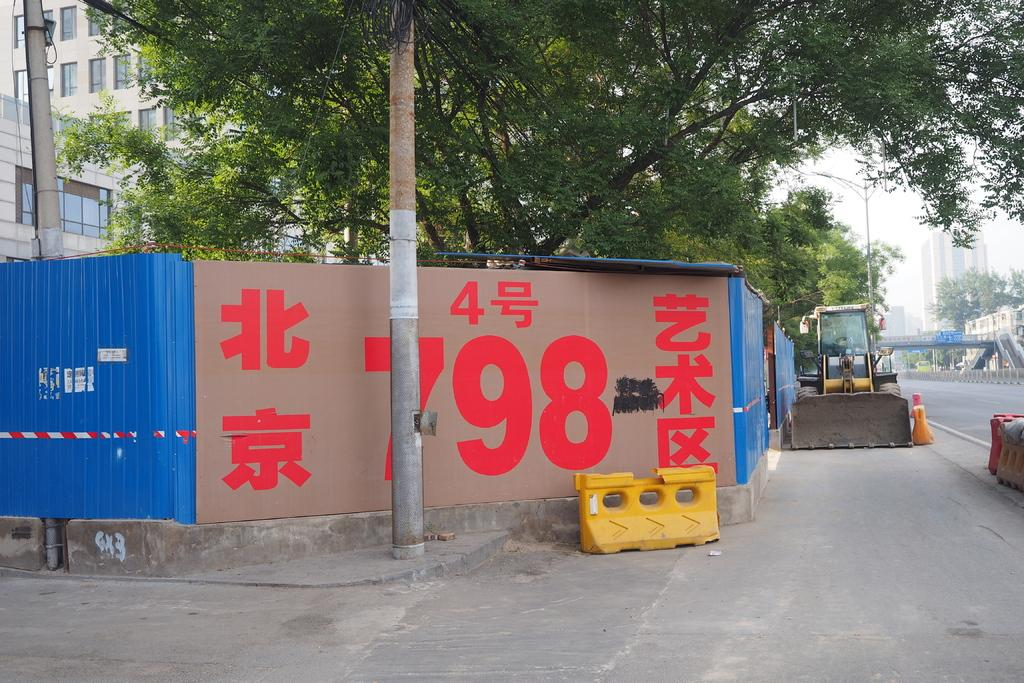Provide a one-sentence caption for the provided image. the word 798 that is on a wall. 